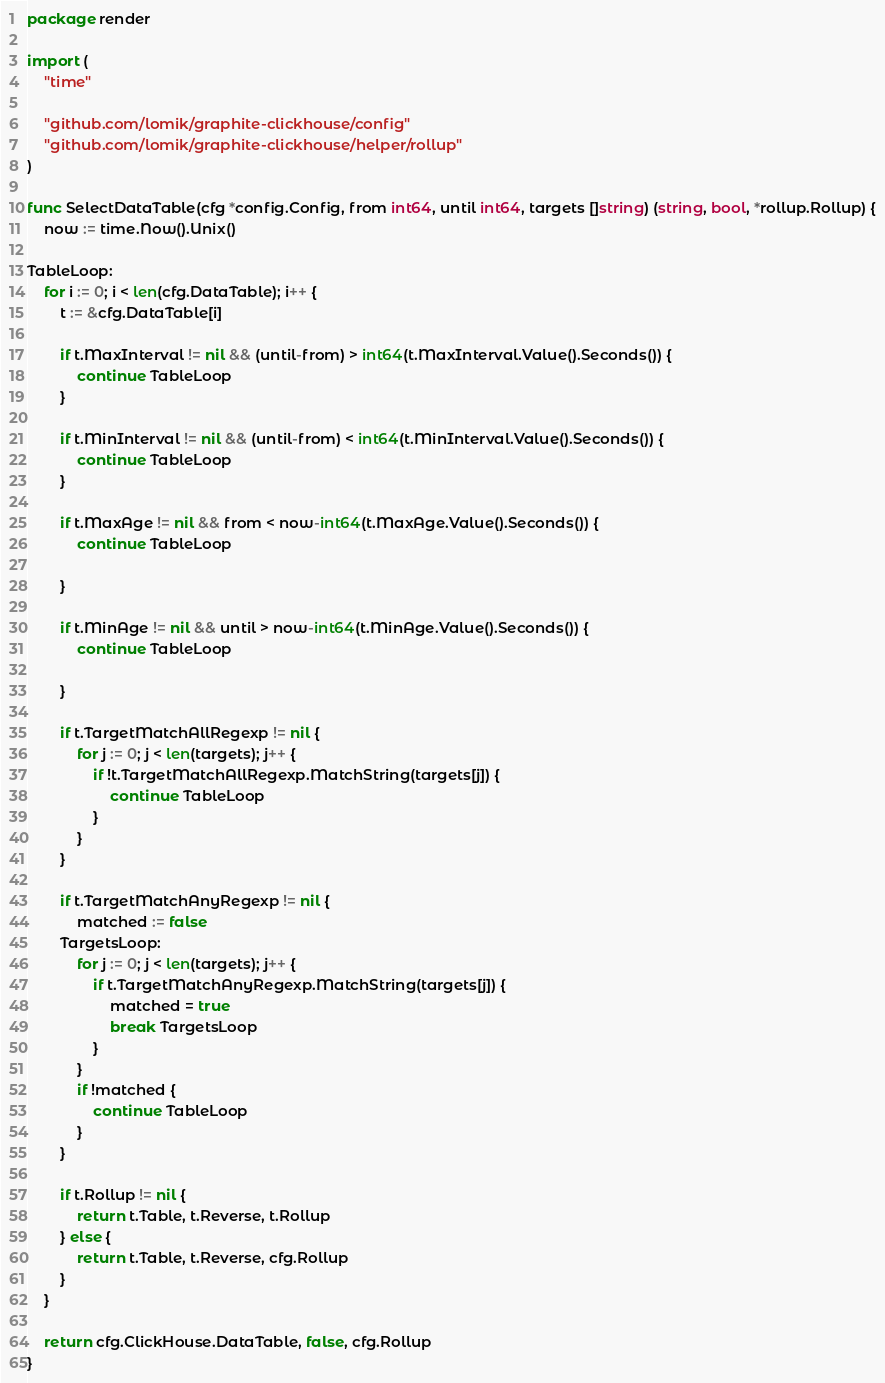Convert code to text. <code><loc_0><loc_0><loc_500><loc_500><_Go_>package render

import (
	"time"

	"github.com/lomik/graphite-clickhouse/config"
	"github.com/lomik/graphite-clickhouse/helper/rollup"
)

func SelectDataTable(cfg *config.Config, from int64, until int64, targets []string) (string, bool, *rollup.Rollup) {
	now := time.Now().Unix()

TableLoop:
	for i := 0; i < len(cfg.DataTable); i++ {
		t := &cfg.DataTable[i]

		if t.MaxInterval != nil && (until-from) > int64(t.MaxInterval.Value().Seconds()) {
			continue TableLoop
		}

		if t.MinInterval != nil && (until-from) < int64(t.MinInterval.Value().Seconds()) {
			continue TableLoop
		}

		if t.MaxAge != nil && from < now-int64(t.MaxAge.Value().Seconds()) {
			continue TableLoop

		}

		if t.MinAge != nil && until > now-int64(t.MinAge.Value().Seconds()) {
			continue TableLoop

		}

		if t.TargetMatchAllRegexp != nil {
			for j := 0; j < len(targets); j++ {
				if !t.TargetMatchAllRegexp.MatchString(targets[j]) {
					continue TableLoop
				}
			}
		}

		if t.TargetMatchAnyRegexp != nil {
			matched := false
		TargetsLoop:
			for j := 0; j < len(targets); j++ {
				if t.TargetMatchAnyRegexp.MatchString(targets[j]) {
					matched = true
					break TargetsLoop
				}
			}
			if !matched {
				continue TableLoop
			}
		}

		if t.Rollup != nil {
			return t.Table, t.Reverse, t.Rollup
		} else {
			return t.Table, t.Reverse, cfg.Rollup
		}
	}

	return cfg.ClickHouse.DataTable, false, cfg.Rollup
}
</code> 